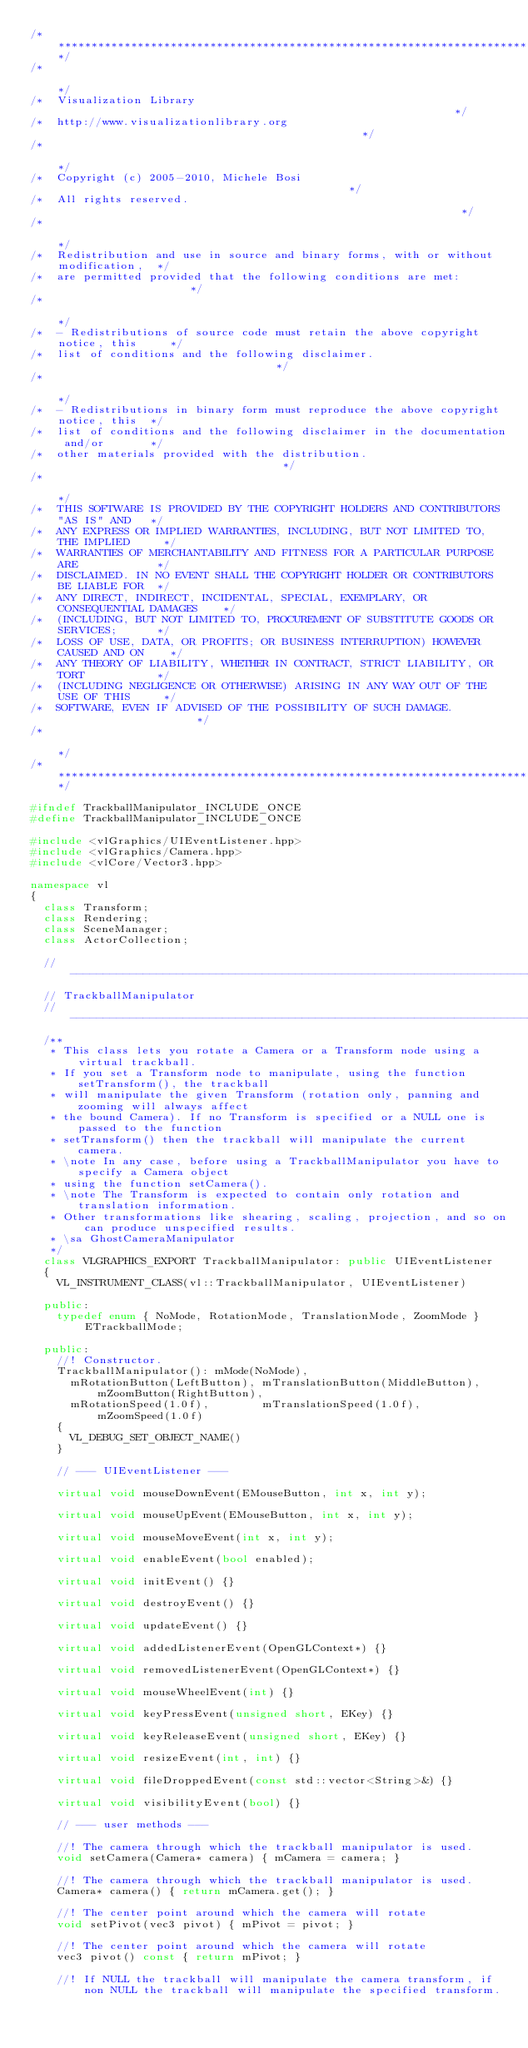Convert code to text. <code><loc_0><loc_0><loc_500><loc_500><_C++_>/**************************************************************************************/
/*                                                                                    */
/*  Visualization Library                                                             */
/*  http://www.visualizationlibrary.org                                               */
/*                                                                                    */
/*  Copyright (c) 2005-2010, Michele Bosi                                             */
/*  All rights reserved.                                                              */
/*                                                                                    */
/*  Redistribution and use in source and binary forms, with or without modification,  */
/*  are permitted provided that the following conditions are met:                     */
/*                                                                                    */
/*  - Redistributions of source code must retain the above copyright notice, this     */
/*  list of conditions and the following disclaimer.                                  */
/*                                                                                    */
/*  - Redistributions in binary form must reproduce the above copyright notice, this  */
/*  list of conditions and the following disclaimer in the documentation and/or       */
/*  other materials provided with the distribution.                                   */
/*                                                                                    */
/*  THIS SOFTWARE IS PROVIDED BY THE COPYRIGHT HOLDERS AND CONTRIBUTORS "AS IS" AND   */
/*  ANY EXPRESS OR IMPLIED WARRANTIES, INCLUDING, BUT NOT LIMITED TO, THE IMPLIED     */
/*  WARRANTIES OF MERCHANTABILITY AND FITNESS FOR A PARTICULAR PURPOSE ARE            */
/*  DISCLAIMED. IN NO EVENT SHALL THE COPYRIGHT HOLDER OR CONTRIBUTORS BE LIABLE FOR  */
/*  ANY DIRECT, INDIRECT, INCIDENTAL, SPECIAL, EXEMPLARY, OR CONSEQUENTIAL DAMAGES    */
/*  (INCLUDING, BUT NOT LIMITED TO, PROCUREMENT OF SUBSTITUTE GOODS OR SERVICES;      */
/*  LOSS OF USE, DATA, OR PROFITS; OR BUSINESS INTERRUPTION) HOWEVER CAUSED AND ON    */
/*  ANY THEORY OF LIABILITY, WHETHER IN CONTRACT, STRICT LIABILITY, OR TORT           */
/*  (INCLUDING NEGLIGENCE OR OTHERWISE) ARISING IN ANY WAY OUT OF THE USE OF THIS     */
/*  SOFTWARE, EVEN IF ADVISED OF THE POSSIBILITY OF SUCH DAMAGE.                      */
/*                                                                                    */
/**************************************************************************************/

#ifndef TrackballManipulator_INCLUDE_ONCE
#define TrackballManipulator_INCLUDE_ONCE

#include <vlGraphics/UIEventListener.hpp>
#include <vlGraphics/Camera.hpp>
#include <vlCore/Vector3.hpp>

namespace vl
{
  class Transform;
  class Rendering;
  class SceneManager;
  class ActorCollection;

  //------------------------------------------------------------------------------
  // TrackballManipulator
  //------------------------------------------------------------------------------
  /**
   * This class lets you rotate a Camera or a Transform node using a virtual trackball.
   * If you set a Transform node to manipulate, using the function setTransform(), the trackball
   * will manipulate the given Transform (rotation only, panning and zooming will always affect 
   * the bound Camera). If no Transform is specified or a NULL one is passed to the function 
   * setTransform() then the trackball will manipulate the current camera.
   * \note In any case, before using a TrackballManipulator you have to specify a Camera object 
   * using the function setCamera().
   * \note The Transform is expected to contain only rotation and translation information. 
   * Other transformations like shearing, scaling, projection, and so on can produce unspecified results.
   * \sa GhostCameraManipulator
   */
  class VLGRAPHICS_EXPORT TrackballManipulator: public UIEventListener
  {
    VL_INSTRUMENT_CLASS(vl::TrackballManipulator, UIEventListener)

  public:
    typedef enum { NoMode, RotationMode, TranslationMode, ZoomMode } ETrackballMode;
  
  public:
    //! Constructor.
    TrackballManipulator(): mMode(NoMode),
      mRotationButton(LeftButton), mTranslationButton(MiddleButton), mZoomButton(RightButton), 
      mRotationSpeed(1.0f),        mTranslationSpeed(1.0f),          mZoomSpeed(1.0f)
    {
      VL_DEBUG_SET_OBJECT_NAME()
    }

    // --- UIEventListener ---

    virtual void mouseDownEvent(EMouseButton, int x, int y);

    virtual void mouseUpEvent(EMouseButton, int x, int y);

    virtual void mouseMoveEvent(int x, int y);

    virtual void enableEvent(bool enabled);

    virtual void initEvent() {}

    virtual void destroyEvent() {}

    virtual void updateEvent() {}
    
    virtual void addedListenerEvent(OpenGLContext*) {}

    virtual void removedListenerEvent(OpenGLContext*) {}

    virtual void mouseWheelEvent(int) {}

    virtual void keyPressEvent(unsigned short, EKey) {}

    virtual void keyReleaseEvent(unsigned short, EKey) {}

    virtual void resizeEvent(int, int) {}

    virtual void fileDroppedEvent(const std::vector<String>&) {}

    virtual void visibilityEvent(bool) {}

    // --- user methods ---

    //! The camera through which the trackball manipulator is used.
    void setCamera(Camera* camera) { mCamera = camera; }

    //! The camera through which the trackball manipulator is used.
    Camera* camera() { return mCamera.get(); }

    //! The center point around which the camera will rotate
    void setPivot(vec3 pivot) { mPivot = pivot; }

    //! The center point around which the camera will rotate
    vec3 pivot() const { return mPivot; }

    //! If NULL the trackball will manipulate the camera transform, if non NULL the trackball will manipulate the specified transform.</code> 